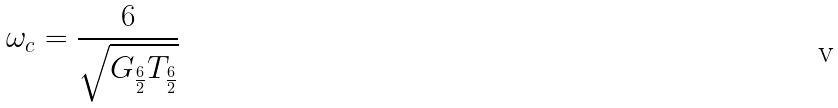<formula> <loc_0><loc_0><loc_500><loc_500>\omega _ { c } = \frac { 6 } { \sqrt { G _ { \frac { 6 } { 2 } } T _ { \frac { 6 } { 2 } } } }</formula> 